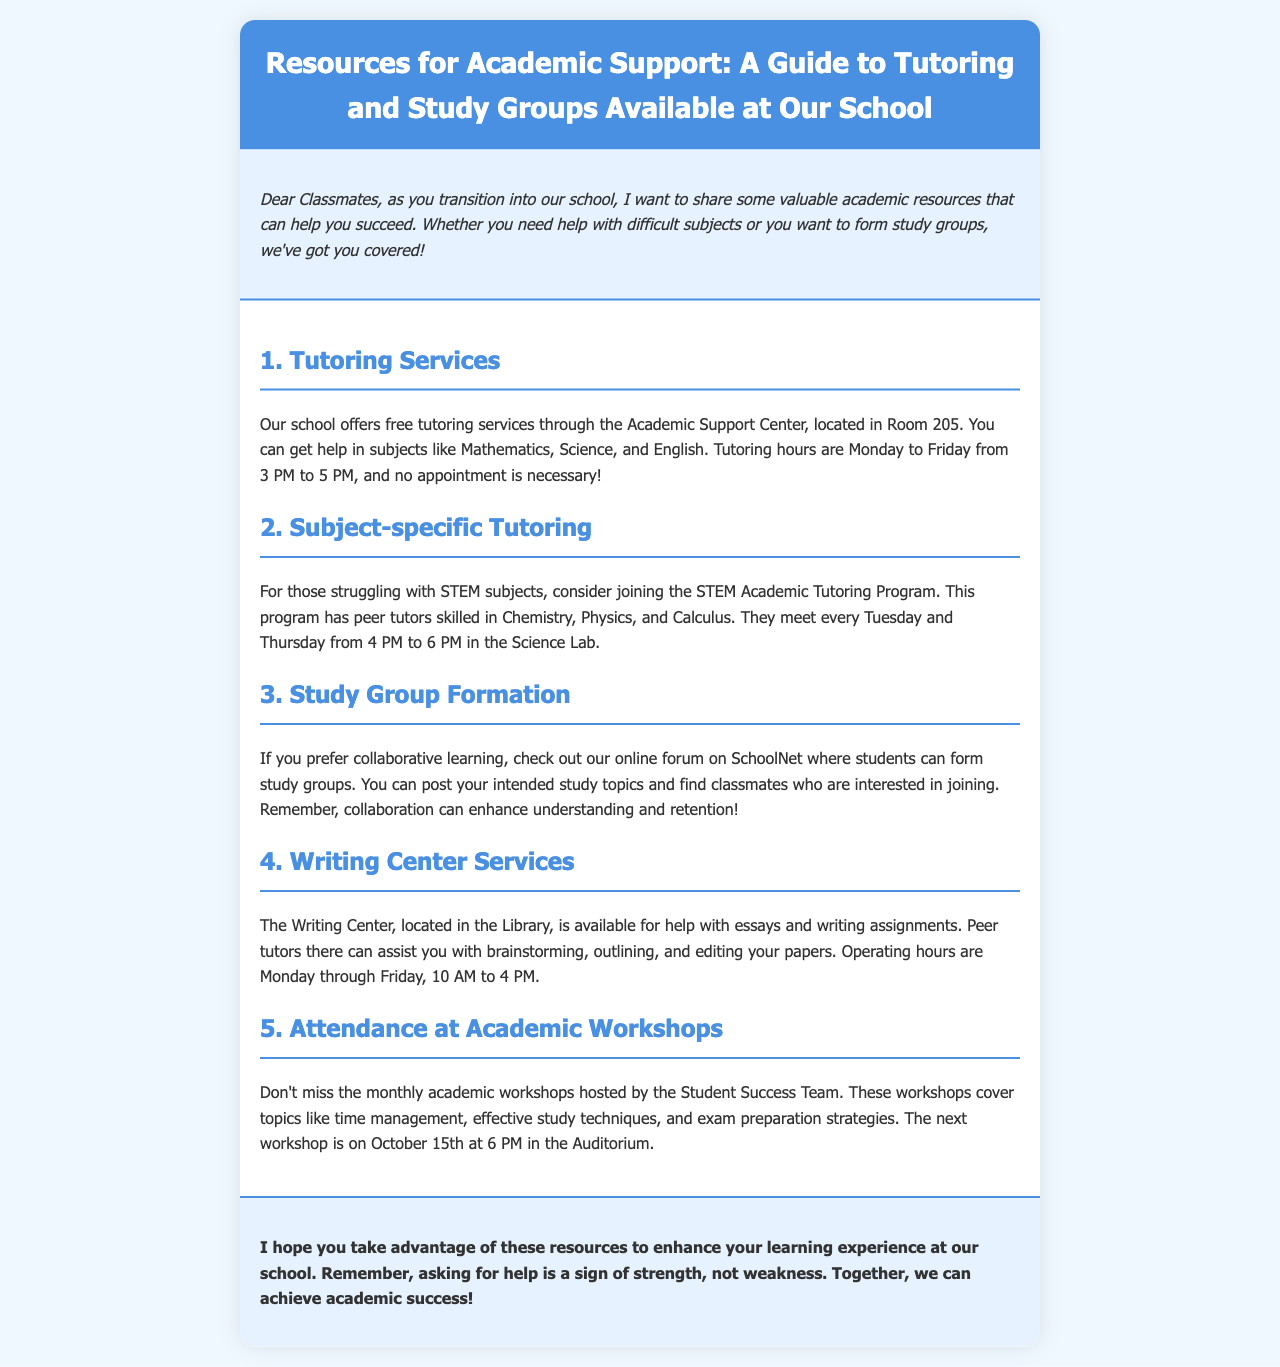what are the tutoring hours? The tutoring hours are specified in the document as Monday to Friday from 3 PM to 5 PM.
Answer: Monday to Friday from 3 PM to 5 PM where is the Academic Support Center located? The document states that the Academic Support Center is located in Room 205.
Answer: Room 205 which subjects does the STEM Academic Tutoring Program cover? The document lists Chemistry, Physics, and Calculus as the subjects covered by the STEM Academic Tutoring Program.
Answer: Chemistry, Physics, and Calculus what is the main purpose of the Writing Center? The main purpose of the Writing Center, as mentioned in the document, is to help with essays and writing assignments.
Answer: Help with essays and writing assignments when is the next academic workshop scheduled? According to the document, the next workshop is scheduled for October 15th at 6 PM.
Answer: October 15th at 6 PM who can assist you in the Writing Center? The document indicates that peer tutors can assist you in the Writing Center.
Answer: Peer tutors how can students form study groups? The document explains that students can form study groups through an online forum on SchoolNet.
Answer: Online forum on SchoolNet what is the focus of the monthly academic workshops? The monthly academic workshops focus on topics like time management, effective study techniques, and exam preparation strategies.
Answer: Time management, effective study techniques, and exam preparation strategies is an appointment necessary for tutoring services? The document states that no appointment is necessary for tutoring services.
Answer: No appointment necessary 